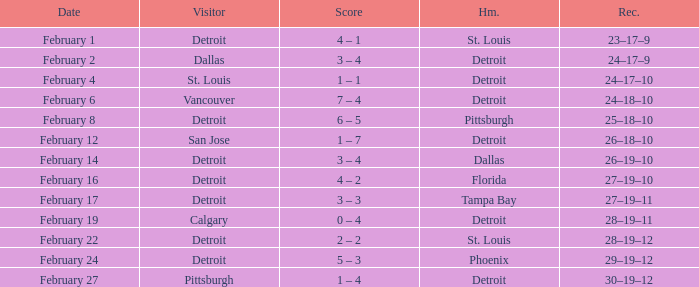What was their record on February 24? 29–19–12. 